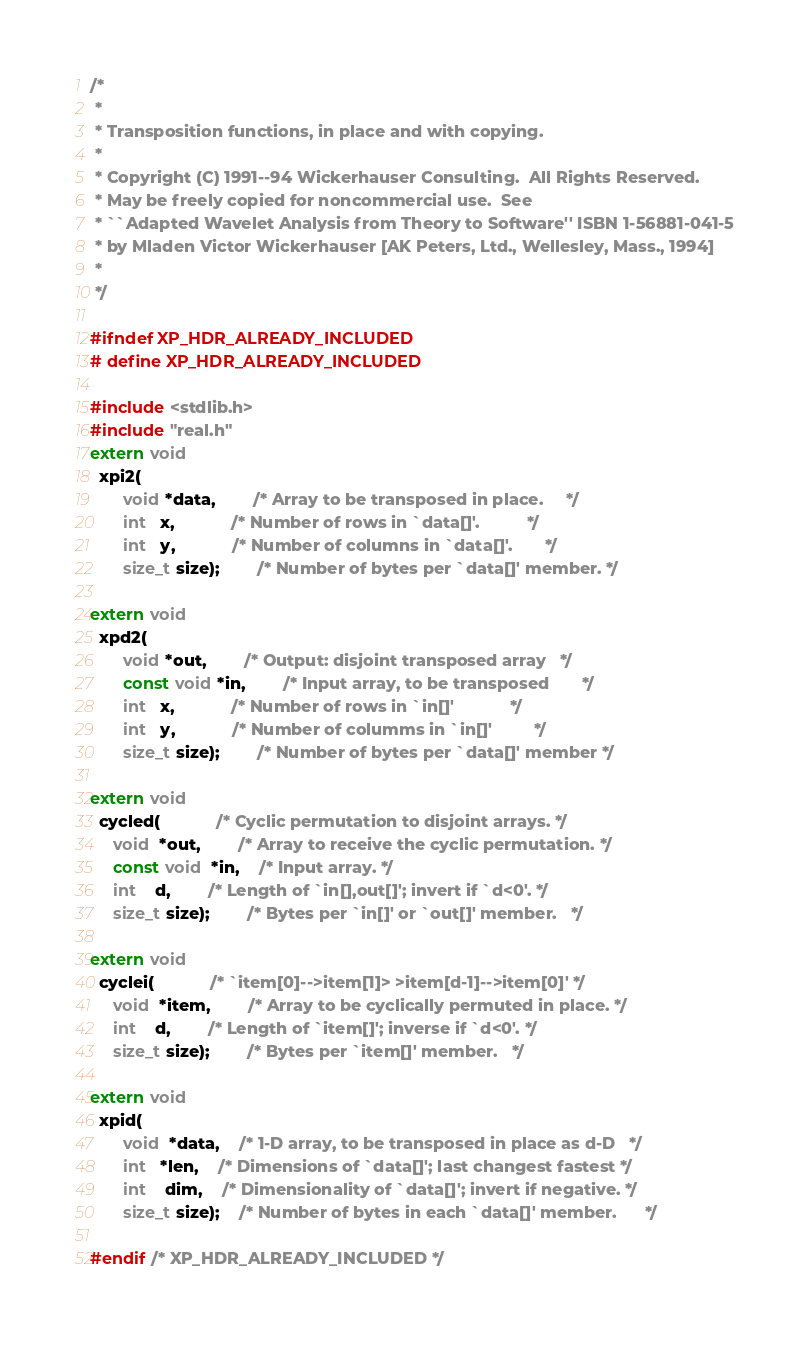<code> <loc_0><loc_0><loc_500><loc_500><_C_>/*
 * 
 * Transposition functions, in place and with copying.
 * 
 * Copyright (C) 1991--94 Wickerhauser Consulting.  All Rights Reserved.
 * May be freely copied for noncommercial use.  See
 * ``Adapted Wavelet Analysis from Theory to Software'' ISBN 1-56881-041-5
 * by Mladen Victor Wickerhauser [AK Peters, Ltd., Wellesley, Mass., 1994]
 * 
 */

#ifndef XP_HDR_ALREADY_INCLUDED
# define XP_HDR_ALREADY_INCLUDED

#include <stdlib.h>
#include "real.h"
extern void
  xpi2(
       void *data,		/* Array to be transposed in place.     */
       int   x,			/* Number of rows in `data[]'.          */
       int   y,			/* Number of columns in `data[]'.       */
       size_t size);		/* Number of bytes per `data[]' member. */

extern void
  xpd2(
       void *out,		/* Output: disjoint transposed array   */
       const void *in,		/* Input array, to be transposed       */
       int   x,			/* Number of rows in `in[]'            */
       int   y,			/* Number of columms in `in[]'         */
       size_t size);		/* Number of bytes per `data[]' member */

extern void
  cycled(			/* Cyclic permutation to disjoint arrays. */
	 void  *out,		/* Array to receive the cyclic permutation. */
	 const void  *in,	/* Input array. */
	 int    d,		/* Length of `in[],out[]'; invert if `d<0'. */
	 size_t size);		/* Bytes per `in[]' or `out[]' member.   */

extern void
  cyclei(			/* `item[0]-->item[1]> >item[d-1]-->item[0]' */
	 void  *item,		/* Array to be cyclically permuted in place. */
	 int    d,		/* Length of `item[]'; inverse if `d<0'. */
	 size_t size);		/* Bytes per `item[]' member.   */

extern void
  xpid(
       void  *data,	/* 1-D array, to be transposed in place as d-D   */
       int   *len,	/* Dimensions of `data[]'; last changest fastest */
       int    dim,	/* Dimensionality of `data[]'; invert if negative. */
       size_t size);	/* Number of bytes in each `data[]' member.      */

#endif /* XP_HDR_ALREADY_INCLUDED */
</code> 